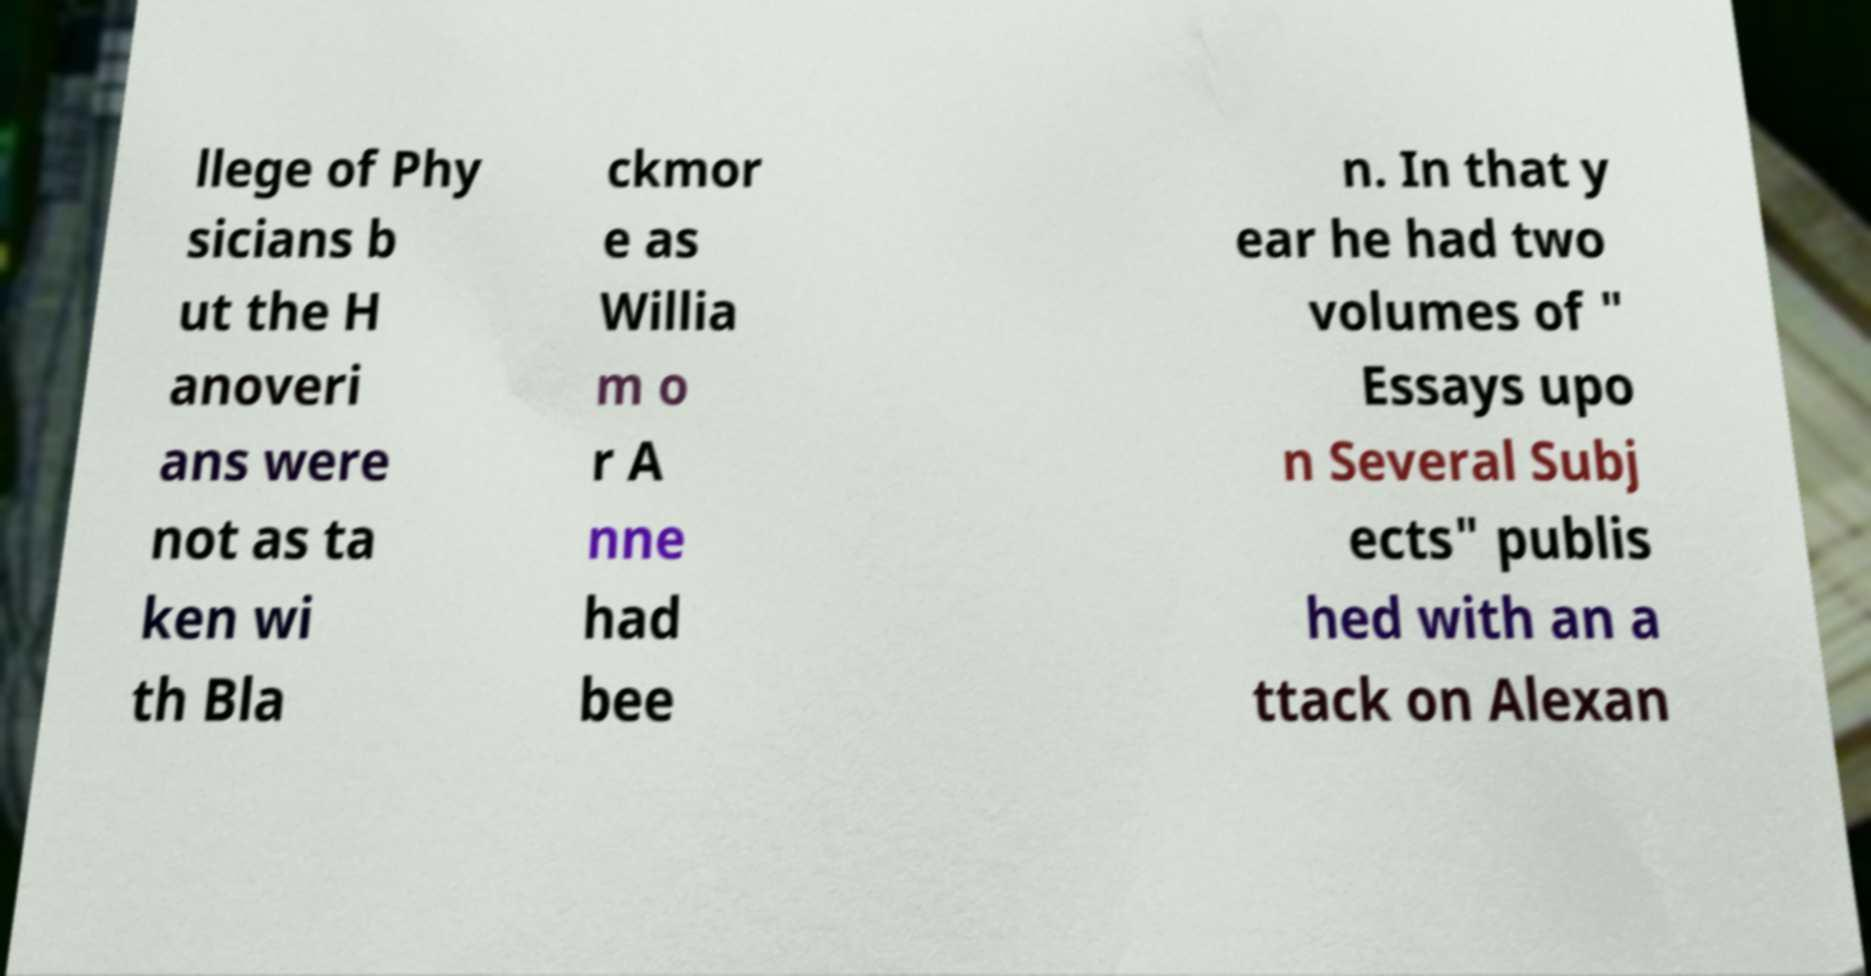What messages or text are displayed in this image? I need them in a readable, typed format. llege of Phy sicians b ut the H anoveri ans were not as ta ken wi th Bla ckmor e as Willia m o r A nne had bee n. In that y ear he had two volumes of " Essays upo n Several Subj ects" publis hed with an a ttack on Alexan 